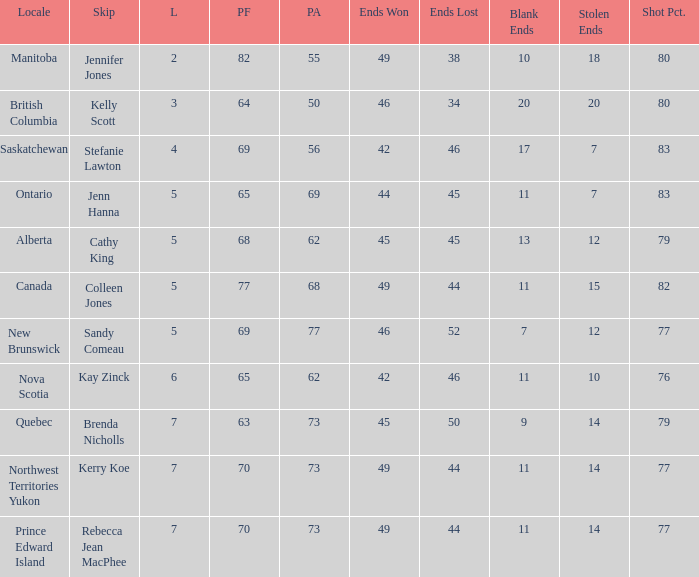What is the total number of ends won when the locale is Northwest Territories Yukon? 1.0. 